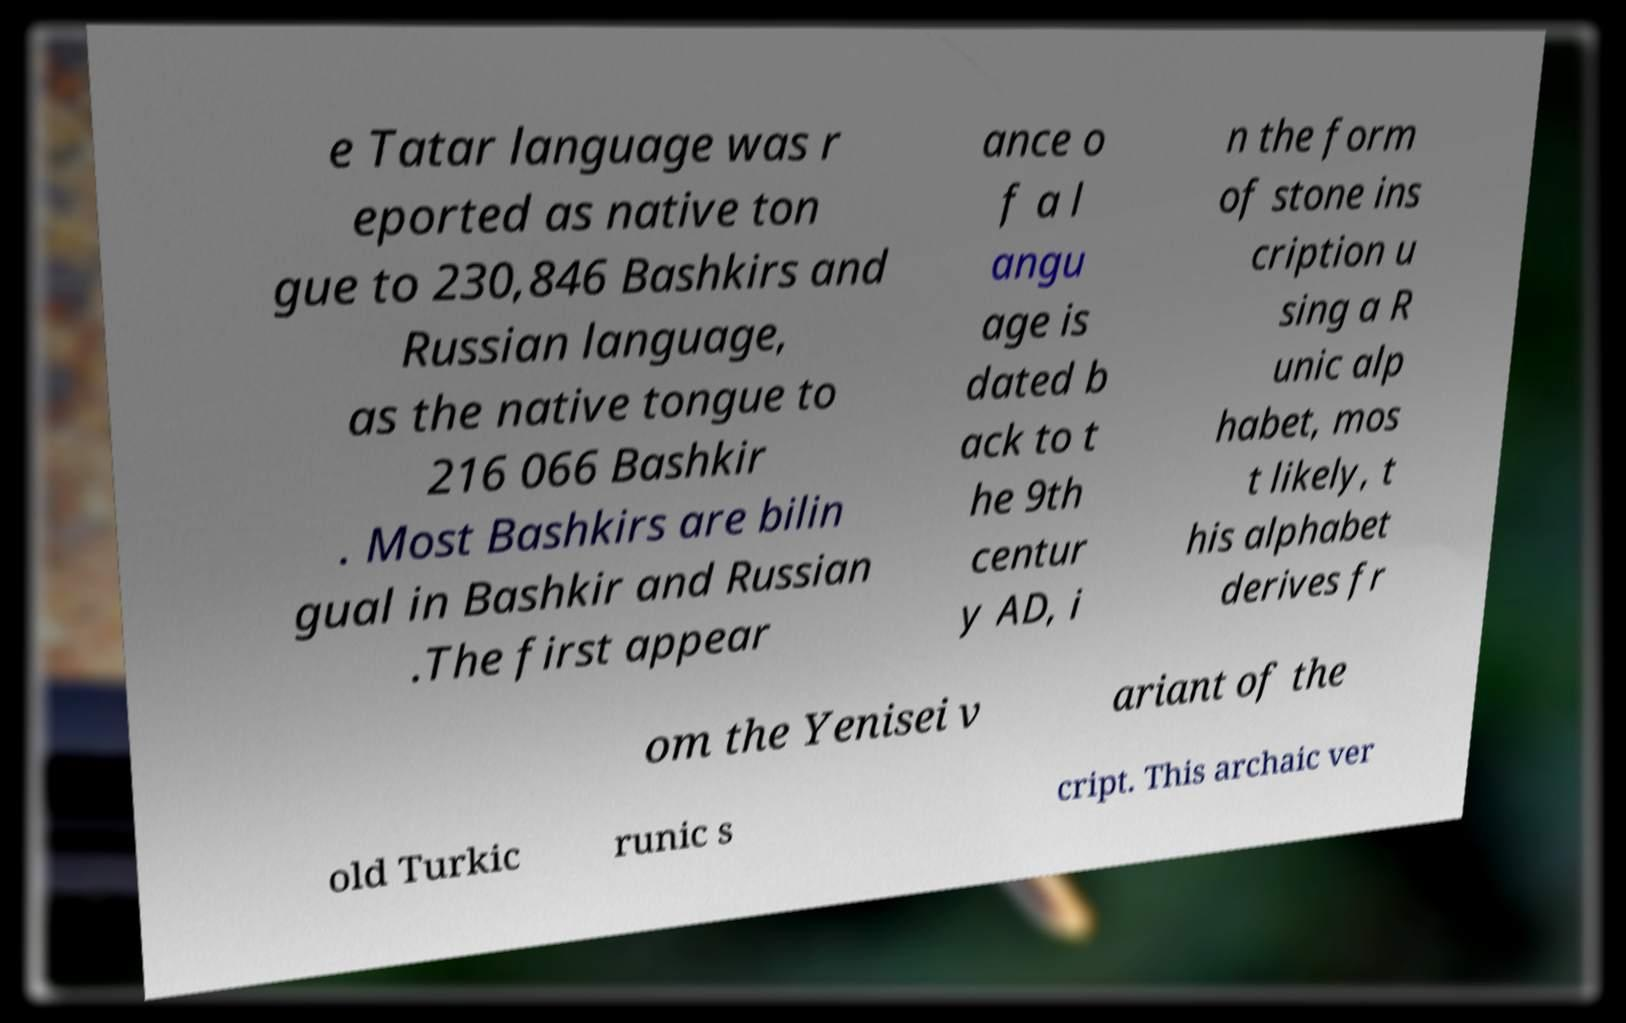Can you accurately transcribe the text from the provided image for me? e Tatar language was r eported as native ton gue to 230,846 Bashkirs and Russian language, as the native tongue to 216 066 Bashkir . Most Bashkirs are bilin gual in Bashkir and Russian .The first appear ance o f a l angu age is dated b ack to t he 9th centur y AD, i n the form of stone ins cription u sing a R unic alp habet, mos t likely, t his alphabet derives fr om the Yenisei v ariant of the old Turkic runic s cript. This archaic ver 